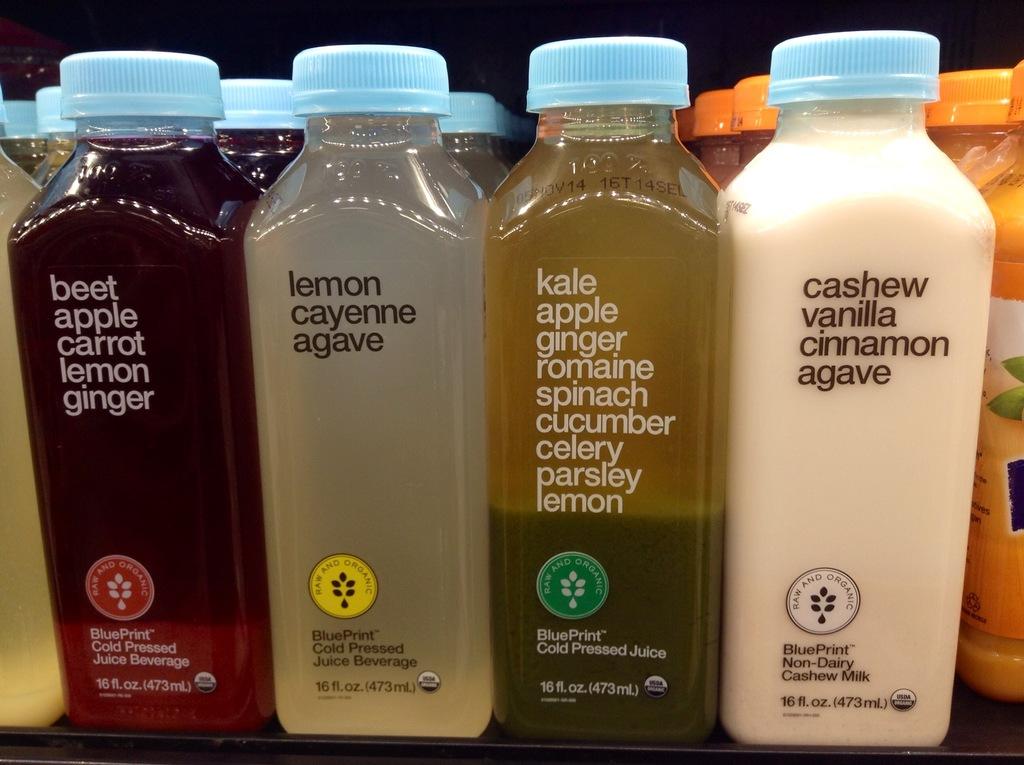What are the five ingredients of the leftmost drink?
Keep it short and to the point. Beet, apple, carrot, lemon, ginger. 